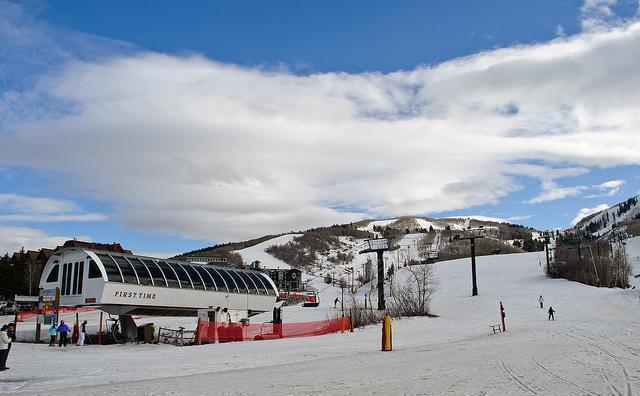Which skiers gather under the pavilion nearest here?
Make your selection from the four choices given to correctly answer the question.
Options: Beginners, retirees, olympians, pros. Beginners. 